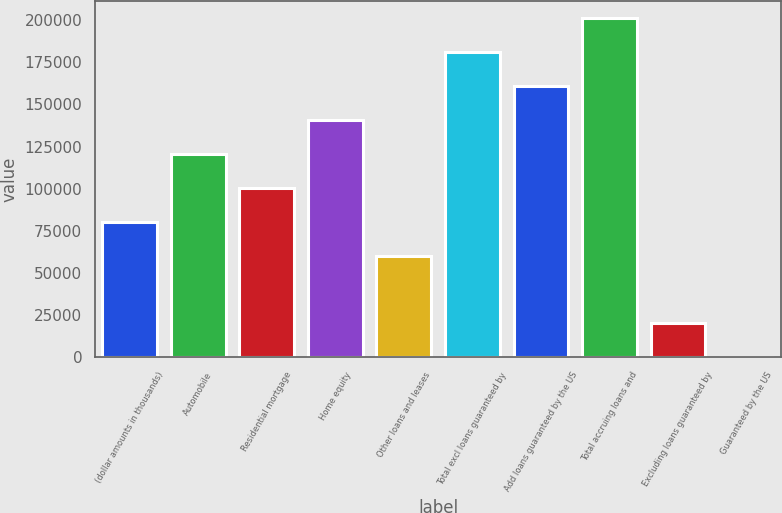Convert chart to OTSL. <chart><loc_0><loc_0><loc_500><loc_500><bar_chart><fcel>(dollar amounts in thousands)<fcel>Automobile<fcel>Residential mortgage<fcel>Home equity<fcel>Other loans and leases<fcel>Total excl loans guaranteed by<fcel>Add loans guaranteed by the US<fcel>Total accruing loans and<fcel>Excluding loans guaranteed by<fcel>Guaranteed by the US<nl><fcel>80452.9<fcel>120679<fcel>100566<fcel>140792<fcel>60339.8<fcel>181019<fcel>160906<fcel>201132<fcel>20113.4<fcel>0.22<nl></chart> 